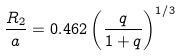Convert formula to latex. <formula><loc_0><loc_0><loc_500><loc_500>\frac { R _ { 2 } } { a } = 0 . 4 6 2 \left ( \frac { q } { 1 + q } \right ) ^ { 1 / 3 }</formula> 